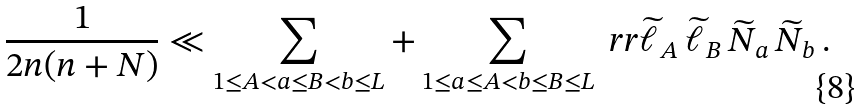Convert formula to latex. <formula><loc_0><loc_0><loc_500><loc_500>\frac { 1 } { 2 n ( n + N ) } \ll \sum _ { 1 \leq A < a \leq B < b \leq L } + \sum _ { 1 \leq a \leq A < b \leq B \leq L } \ r r \widetilde { \ell } _ { A } \, \widetilde { \ell } _ { B } \, \widetilde { N } _ { a } \, \widetilde { N } _ { b } \, .</formula> 